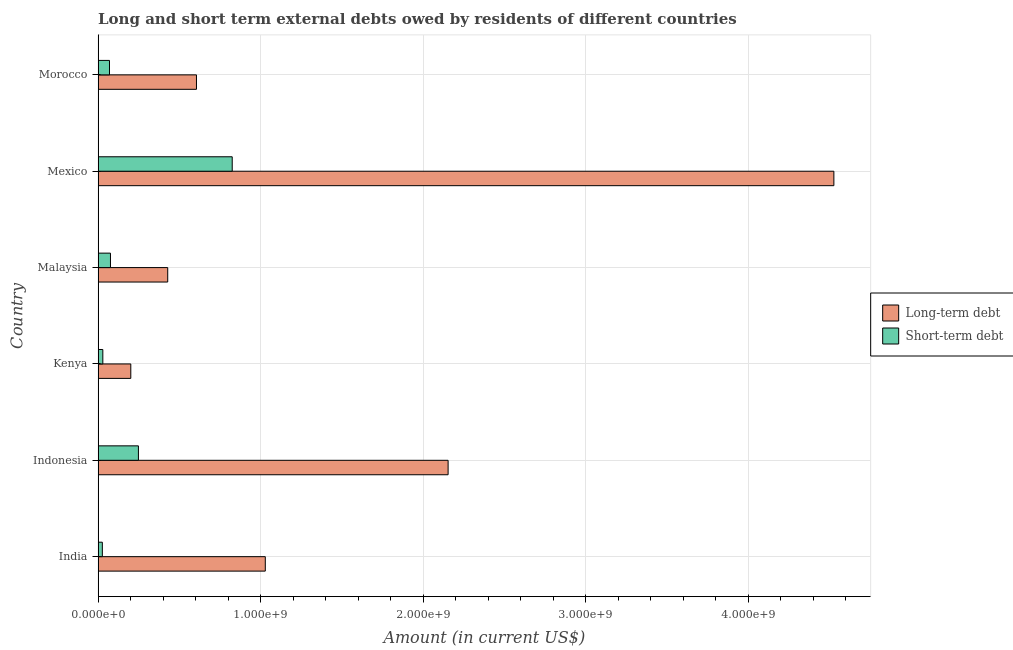Are the number of bars on each tick of the Y-axis equal?
Offer a terse response. Yes. How many bars are there on the 6th tick from the bottom?
Your response must be concise. 2. What is the label of the 4th group of bars from the top?
Provide a succinct answer. Kenya. In how many cases, is the number of bars for a given country not equal to the number of legend labels?
Offer a very short reply. 0. What is the short-term debts owed by residents in Kenya?
Offer a terse response. 2.90e+07. Across all countries, what is the maximum long-term debts owed by residents?
Offer a very short reply. 4.53e+09. Across all countries, what is the minimum short-term debts owed by residents?
Offer a terse response. 2.60e+07. In which country was the long-term debts owed by residents maximum?
Provide a succinct answer. Mexico. In which country was the short-term debts owed by residents minimum?
Offer a terse response. India. What is the total short-term debts owed by residents in the graph?
Your response must be concise. 1.27e+09. What is the difference between the long-term debts owed by residents in Malaysia and that in Morocco?
Provide a succinct answer. -1.77e+08. What is the difference between the short-term debts owed by residents in Morocco and the long-term debts owed by residents in India?
Provide a short and direct response. -9.58e+08. What is the average long-term debts owed by residents per country?
Your response must be concise. 1.49e+09. What is the difference between the long-term debts owed by residents and short-term debts owed by residents in Malaysia?
Give a very brief answer. 3.52e+08. What is the ratio of the short-term debts owed by residents in Indonesia to that in Morocco?
Ensure brevity in your answer.  3.54. Is the short-term debts owed by residents in Kenya less than that in Mexico?
Offer a terse response. Yes. What is the difference between the highest and the second highest long-term debts owed by residents?
Give a very brief answer. 2.37e+09. What is the difference between the highest and the lowest long-term debts owed by residents?
Give a very brief answer. 4.33e+09. In how many countries, is the short-term debts owed by residents greater than the average short-term debts owed by residents taken over all countries?
Offer a terse response. 2. What does the 1st bar from the top in India represents?
Give a very brief answer. Short-term debt. What does the 2nd bar from the bottom in Morocco represents?
Your answer should be very brief. Short-term debt. Are all the bars in the graph horizontal?
Make the answer very short. Yes. How many countries are there in the graph?
Ensure brevity in your answer.  6. Where does the legend appear in the graph?
Keep it short and to the point. Center right. How are the legend labels stacked?
Make the answer very short. Vertical. What is the title of the graph?
Keep it short and to the point. Long and short term external debts owed by residents of different countries. What is the Amount (in current US$) in Long-term debt in India?
Keep it short and to the point. 1.03e+09. What is the Amount (in current US$) of Short-term debt in India?
Offer a terse response. 2.60e+07. What is the Amount (in current US$) of Long-term debt in Indonesia?
Offer a terse response. 2.15e+09. What is the Amount (in current US$) of Short-term debt in Indonesia?
Give a very brief answer. 2.48e+08. What is the Amount (in current US$) of Long-term debt in Kenya?
Make the answer very short. 2.01e+08. What is the Amount (in current US$) of Short-term debt in Kenya?
Offer a terse response. 2.90e+07. What is the Amount (in current US$) in Long-term debt in Malaysia?
Your response must be concise. 4.28e+08. What is the Amount (in current US$) in Short-term debt in Malaysia?
Your answer should be very brief. 7.60e+07. What is the Amount (in current US$) in Long-term debt in Mexico?
Give a very brief answer. 4.53e+09. What is the Amount (in current US$) in Short-term debt in Mexico?
Your answer should be very brief. 8.25e+08. What is the Amount (in current US$) in Long-term debt in Morocco?
Provide a short and direct response. 6.05e+08. What is the Amount (in current US$) of Short-term debt in Morocco?
Provide a succinct answer. 7.00e+07. Across all countries, what is the maximum Amount (in current US$) of Long-term debt?
Your answer should be compact. 4.53e+09. Across all countries, what is the maximum Amount (in current US$) in Short-term debt?
Ensure brevity in your answer.  8.25e+08. Across all countries, what is the minimum Amount (in current US$) in Long-term debt?
Your answer should be compact. 2.01e+08. Across all countries, what is the minimum Amount (in current US$) of Short-term debt?
Your answer should be very brief. 2.60e+07. What is the total Amount (in current US$) of Long-term debt in the graph?
Your answer should be compact. 8.94e+09. What is the total Amount (in current US$) in Short-term debt in the graph?
Your answer should be very brief. 1.27e+09. What is the difference between the Amount (in current US$) of Long-term debt in India and that in Indonesia?
Offer a very short reply. -1.12e+09. What is the difference between the Amount (in current US$) of Short-term debt in India and that in Indonesia?
Give a very brief answer. -2.22e+08. What is the difference between the Amount (in current US$) of Long-term debt in India and that in Kenya?
Ensure brevity in your answer.  8.27e+08. What is the difference between the Amount (in current US$) in Short-term debt in India and that in Kenya?
Provide a succinct answer. -3.00e+06. What is the difference between the Amount (in current US$) of Long-term debt in India and that in Malaysia?
Offer a very short reply. 6.00e+08. What is the difference between the Amount (in current US$) in Short-term debt in India and that in Malaysia?
Your response must be concise. -5.00e+07. What is the difference between the Amount (in current US$) of Long-term debt in India and that in Mexico?
Ensure brevity in your answer.  -3.50e+09. What is the difference between the Amount (in current US$) of Short-term debt in India and that in Mexico?
Offer a terse response. -7.99e+08. What is the difference between the Amount (in current US$) in Long-term debt in India and that in Morocco?
Provide a short and direct response. 4.23e+08. What is the difference between the Amount (in current US$) of Short-term debt in India and that in Morocco?
Offer a very short reply. -4.40e+07. What is the difference between the Amount (in current US$) in Long-term debt in Indonesia and that in Kenya?
Your answer should be compact. 1.95e+09. What is the difference between the Amount (in current US$) of Short-term debt in Indonesia and that in Kenya?
Provide a short and direct response. 2.19e+08. What is the difference between the Amount (in current US$) of Long-term debt in Indonesia and that in Malaysia?
Make the answer very short. 1.73e+09. What is the difference between the Amount (in current US$) in Short-term debt in Indonesia and that in Malaysia?
Offer a terse response. 1.72e+08. What is the difference between the Amount (in current US$) of Long-term debt in Indonesia and that in Mexico?
Make the answer very short. -2.37e+09. What is the difference between the Amount (in current US$) in Short-term debt in Indonesia and that in Mexico?
Your answer should be compact. -5.77e+08. What is the difference between the Amount (in current US$) in Long-term debt in Indonesia and that in Morocco?
Offer a terse response. 1.55e+09. What is the difference between the Amount (in current US$) of Short-term debt in Indonesia and that in Morocco?
Offer a terse response. 1.78e+08. What is the difference between the Amount (in current US$) in Long-term debt in Kenya and that in Malaysia?
Your answer should be very brief. -2.27e+08. What is the difference between the Amount (in current US$) in Short-term debt in Kenya and that in Malaysia?
Offer a terse response. -4.70e+07. What is the difference between the Amount (in current US$) of Long-term debt in Kenya and that in Mexico?
Ensure brevity in your answer.  -4.33e+09. What is the difference between the Amount (in current US$) of Short-term debt in Kenya and that in Mexico?
Offer a very short reply. -7.96e+08. What is the difference between the Amount (in current US$) of Long-term debt in Kenya and that in Morocco?
Offer a very short reply. -4.04e+08. What is the difference between the Amount (in current US$) of Short-term debt in Kenya and that in Morocco?
Your answer should be very brief. -4.10e+07. What is the difference between the Amount (in current US$) in Long-term debt in Malaysia and that in Mexico?
Your answer should be very brief. -4.10e+09. What is the difference between the Amount (in current US$) in Short-term debt in Malaysia and that in Mexico?
Offer a very short reply. -7.49e+08. What is the difference between the Amount (in current US$) of Long-term debt in Malaysia and that in Morocco?
Your answer should be compact. -1.77e+08. What is the difference between the Amount (in current US$) in Long-term debt in Mexico and that in Morocco?
Give a very brief answer. 3.92e+09. What is the difference between the Amount (in current US$) in Short-term debt in Mexico and that in Morocco?
Give a very brief answer. 7.55e+08. What is the difference between the Amount (in current US$) in Long-term debt in India and the Amount (in current US$) in Short-term debt in Indonesia?
Provide a succinct answer. 7.80e+08. What is the difference between the Amount (in current US$) in Long-term debt in India and the Amount (in current US$) in Short-term debt in Kenya?
Keep it short and to the point. 9.99e+08. What is the difference between the Amount (in current US$) in Long-term debt in India and the Amount (in current US$) in Short-term debt in Malaysia?
Your answer should be compact. 9.52e+08. What is the difference between the Amount (in current US$) of Long-term debt in India and the Amount (in current US$) of Short-term debt in Mexico?
Provide a short and direct response. 2.03e+08. What is the difference between the Amount (in current US$) of Long-term debt in India and the Amount (in current US$) of Short-term debt in Morocco?
Ensure brevity in your answer.  9.58e+08. What is the difference between the Amount (in current US$) in Long-term debt in Indonesia and the Amount (in current US$) in Short-term debt in Kenya?
Provide a succinct answer. 2.12e+09. What is the difference between the Amount (in current US$) in Long-term debt in Indonesia and the Amount (in current US$) in Short-term debt in Malaysia?
Keep it short and to the point. 2.08e+09. What is the difference between the Amount (in current US$) in Long-term debt in Indonesia and the Amount (in current US$) in Short-term debt in Mexico?
Your answer should be compact. 1.33e+09. What is the difference between the Amount (in current US$) of Long-term debt in Indonesia and the Amount (in current US$) of Short-term debt in Morocco?
Ensure brevity in your answer.  2.08e+09. What is the difference between the Amount (in current US$) of Long-term debt in Kenya and the Amount (in current US$) of Short-term debt in Malaysia?
Your answer should be compact. 1.25e+08. What is the difference between the Amount (in current US$) of Long-term debt in Kenya and the Amount (in current US$) of Short-term debt in Mexico?
Make the answer very short. -6.24e+08. What is the difference between the Amount (in current US$) in Long-term debt in Kenya and the Amount (in current US$) in Short-term debt in Morocco?
Ensure brevity in your answer.  1.31e+08. What is the difference between the Amount (in current US$) in Long-term debt in Malaysia and the Amount (in current US$) in Short-term debt in Mexico?
Your answer should be very brief. -3.97e+08. What is the difference between the Amount (in current US$) of Long-term debt in Malaysia and the Amount (in current US$) of Short-term debt in Morocco?
Your answer should be very brief. 3.58e+08. What is the difference between the Amount (in current US$) in Long-term debt in Mexico and the Amount (in current US$) in Short-term debt in Morocco?
Your response must be concise. 4.46e+09. What is the average Amount (in current US$) of Long-term debt per country?
Offer a terse response. 1.49e+09. What is the average Amount (in current US$) in Short-term debt per country?
Your response must be concise. 2.12e+08. What is the difference between the Amount (in current US$) in Long-term debt and Amount (in current US$) in Short-term debt in India?
Offer a terse response. 1.00e+09. What is the difference between the Amount (in current US$) of Long-term debt and Amount (in current US$) of Short-term debt in Indonesia?
Your response must be concise. 1.91e+09. What is the difference between the Amount (in current US$) in Long-term debt and Amount (in current US$) in Short-term debt in Kenya?
Your answer should be compact. 1.72e+08. What is the difference between the Amount (in current US$) in Long-term debt and Amount (in current US$) in Short-term debt in Malaysia?
Give a very brief answer. 3.52e+08. What is the difference between the Amount (in current US$) of Long-term debt and Amount (in current US$) of Short-term debt in Mexico?
Provide a succinct answer. 3.70e+09. What is the difference between the Amount (in current US$) of Long-term debt and Amount (in current US$) of Short-term debt in Morocco?
Provide a short and direct response. 5.35e+08. What is the ratio of the Amount (in current US$) in Long-term debt in India to that in Indonesia?
Provide a short and direct response. 0.48. What is the ratio of the Amount (in current US$) of Short-term debt in India to that in Indonesia?
Keep it short and to the point. 0.1. What is the ratio of the Amount (in current US$) in Long-term debt in India to that in Kenya?
Your answer should be very brief. 5.12. What is the ratio of the Amount (in current US$) of Short-term debt in India to that in Kenya?
Give a very brief answer. 0.9. What is the ratio of the Amount (in current US$) in Long-term debt in India to that in Malaysia?
Your answer should be very brief. 2.4. What is the ratio of the Amount (in current US$) of Short-term debt in India to that in Malaysia?
Make the answer very short. 0.34. What is the ratio of the Amount (in current US$) of Long-term debt in India to that in Mexico?
Provide a succinct answer. 0.23. What is the ratio of the Amount (in current US$) of Short-term debt in India to that in Mexico?
Make the answer very short. 0.03. What is the ratio of the Amount (in current US$) in Long-term debt in India to that in Morocco?
Keep it short and to the point. 1.7. What is the ratio of the Amount (in current US$) in Short-term debt in India to that in Morocco?
Provide a short and direct response. 0.37. What is the ratio of the Amount (in current US$) in Long-term debt in Indonesia to that in Kenya?
Provide a short and direct response. 10.71. What is the ratio of the Amount (in current US$) in Short-term debt in Indonesia to that in Kenya?
Offer a terse response. 8.55. What is the ratio of the Amount (in current US$) in Long-term debt in Indonesia to that in Malaysia?
Make the answer very short. 5.03. What is the ratio of the Amount (in current US$) in Short-term debt in Indonesia to that in Malaysia?
Your answer should be compact. 3.26. What is the ratio of the Amount (in current US$) of Long-term debt in Indonesia to that in Mexico?
Make the answer very short. 0.48. What is the ratio of the Amount (in current US$) in Short-term debt in Indonesia to that in Mexico?
Offer a very short reply. 0.3. What is the ratio of the Amount (in current US$) of Long-term debt in Indonesia to that in Morocco?
Offer a very short reply. 3.56. What is the ratio of the Amount (in current US$) in Short-term debt in Indonesia to that in Morocco?
Keep it short and to the point. 3.54. What is the ratio of the Amount (in current US$) of Long-term debt in Kenya to that in Malaysia?
Keep it short and to the point. 0.47. What is the ratio of the Amount (in current US$) in Short-term debt in Kenya to that in Malaysia?
Ensure brevity in your answer.  0.38. What is the ratio of the Amount (in current US$) in Long-term debt in Kenya to that in Mexico?
Provide a short and direct response. 0.04. What is the ratio of the Amount (in current US$) of Short-term debt in Kenya to that in Mexico?
Give a very brief answer. 0.04. What is the ratio of the Amount (in current US$) in Long-term debt in Kenya to that in Morocco?
Offer a very short reply. 0.33. What is the ratio of the Amount (in current US$) of Short-term debt in Kenya to that in Morocco?
Make the answer very short. 0.41. What is the ratio of the Amount (in current US$) of Long-term debt in Malaysia to that in Mexico?
Ensure brevity in your answer.  0.09. What is the ratio of the Amount (in current US$) in Short-term debt in Malaysia to that in Mexico?
Your response must be concise. 0.09. What is the ratio of the Amount (in current US$) in Long-term debt in Malaysia to that in Morocco?
Provide a succinct answer. 0.71. What is the ratio of the Amount (in current US$) in Short-term debt in Malaysia to that in Morocco?
Offer a very short reply. 1.09. What is the ratio of the Amount (in current US$) of Long-term debt in Mexico to that in Morocco?
Make the answer very short. 7.48. What is the ratio of the Amount (in current US$) of Short-term debt in Mexico to that in Morocco?
Your answer should be compact. 11.79. What is the difference between the highest and the second highest Amount (in current US$) in Long-term debt?
Your answer should be compact. 2.37e+09. What is the difference between the highest and the second highest Amount (in current US$) in Short-term debt?
Provide a succinct answer. 5.77e+08. What is the difference between the highest and the lowest Amount (in current US$) in Long-term debt?
Your answer should be compact. 4.33e+09. What is the difference between the highest and the lowest Amount (in current US$) of Short-term debt?
Your answer should be compact. 7.99e+08. 